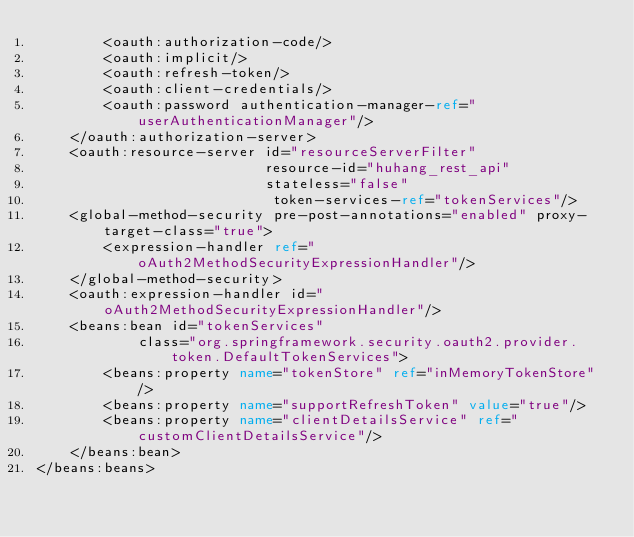<code> <loc_0><loc_0><loc_500><loc_500><_XML_>        <oauth:authorization-code/>
        <oauth:implicit/>
        <oauth:refresh-token/>
        <oauth:client-credentials/>
        <oauth:password authentication-manager-ref="userAuthenticationManager"/>
    </oauth:authorization-server>
    <oauth:resource-server id="resourceServerFilter"
                           resource-id="huhang_rest_api"
                           stateless="false"
                            token-services-ref="tokenServices"/>
    <global-method-security pre-post-annotations="enabled" proxy-target-class="true">
        <expression-handler ref="oAuth2MethodSecurityExpressionHandler"/>
    </global-method-security>
    <oauth:expression-handler id="oAuth2MethodSecurityExpressionHandler"/>
    <beans:bean id="tokenServices"
            class="org.springframework.security.oauth2.provider.token.DefaultTokenServices">
        <beans:property name="tokenStore" ref="inMemoryTokenStore"/>
        <beans:property name="supportRefreshToken" value="true"/>
        <beans:property name="clientDetailsService" ref="customClientDetailsService"/>
    </beans:bean>
</beans:beans></code> 